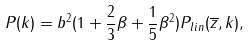<formula> <loc_0><loc_0><loc_500><loc_500>P ( k ) = b ^ { 2 } ( 1 + \frac { 2 } { 3 } \beta + \frac { 1 } { 5 } \beta ^ { 2 } ) P _ { l i n } ( \overline { z } , k ) ,</formula> 